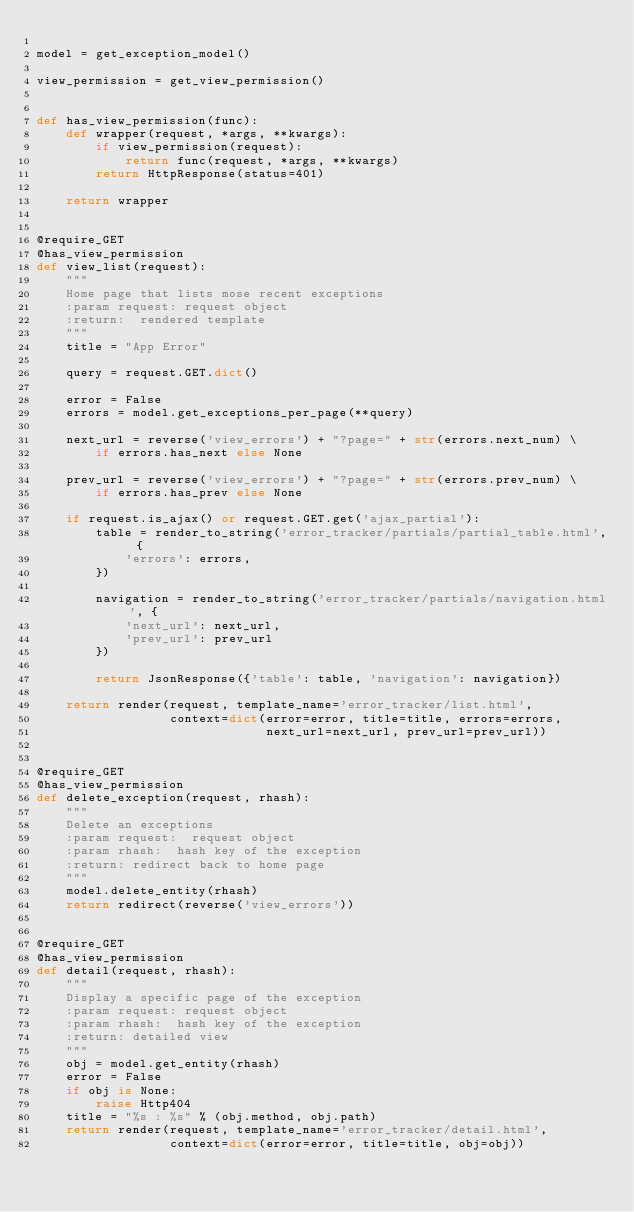Convert code to text. <code><loc_0><loc_0><loc_500><loc_500><_Python_>
model = get_exception_model()

view_permission = get_view_permission()


def has_view_permission(func):
    def wrapper(request, *args, **kwargs):
        if view_permission(request):
            return func(request, *args, **kwargs)
        return HttpResponse(status=401)

    return wrapper


@require_GET
@has_view_permission
def view_list(request):
    """
    Home page that lists mose recent exceptions
    :param request: request object
    :return:  rendered template
    """
    title = "App Error"
    
    query = request.GET.dict()
    
    error = False
    errors = model.get_exceptions_per_page(**query)
   
    next_url = reverse('view_errors') + "?page=" + str(errors.next_num) \
        if errors.has_next else None

    prev_url = reverse('view_errors') + "?page=" + str(errors.prev_num) \
        if errors.has_prev else None

    if request.is_ajax() or request.GET.get('ajax_partial'):
        table = render_to_string('error_tracker/partials/partial_table.html', {
            'errors': errors,
        })

        navigation = render_to_string('error_tracker/partials/navigation.html', {
            'next_url': next_url,
            'prev_url': prev_url
        })

        return JsonResponse({'table': table, 'navigation': navigation})

    return render(request, template_name='error_tracker/list.html',
                  context=dict(error=error, title=title, errors=errors,
                               next_url=next_url, prev_url=prev_url))


@require_GET
@has_view_permission
def delete_exception(request, rhash):
    """
    Delete an exceptions
    :param request:  request object
    :param rhash:  hash key of the exception
    :return: redirect back to home page
    """
    model.delete_entity(rhash)
    return redirect(reverse('view_errors'))


@require_GET
@has_view_permission
def detail(request, rhash):
    """
    Display a specific page of the exception
    :param request: request object
    :param rhash:  hash key of the exception
    :return: detailed view
    """
    obj = model.get_entity(rhash)
    error = False
    if obj is None:
        raise Http404
    title = "%s : %s" % (obj.method, obj.path)
    return render(request, template_name='error_tracker/detail.html',
                  context=dict(error=error, title=title, obj=obj))
</code> 